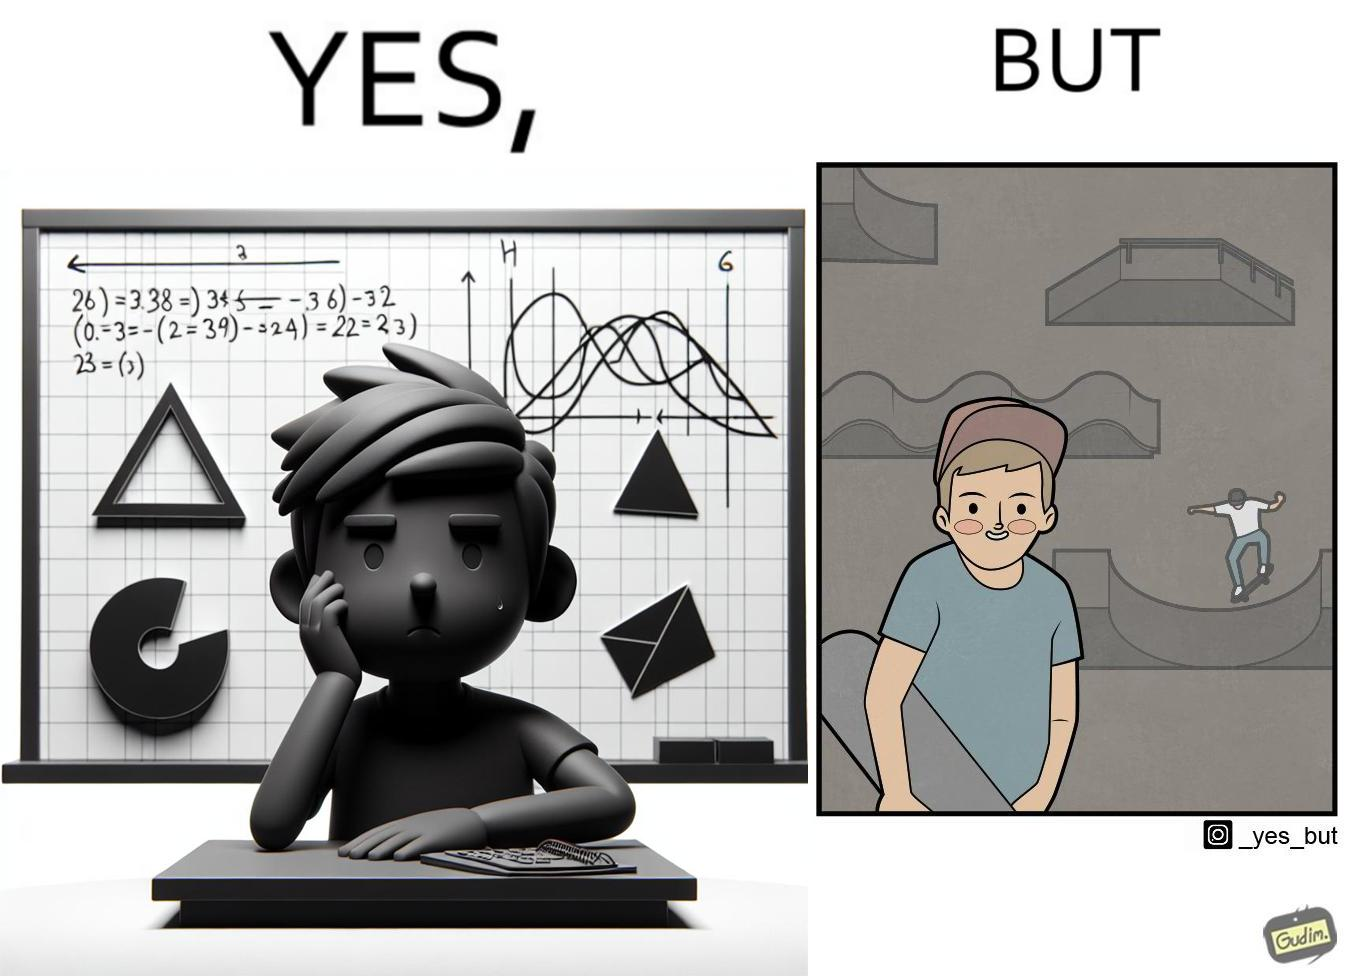Explain the humor or irony in this image. The image is ironical beaucse while the boy does not enjoy studying mathematics and different geometric shapes like semi circle and trapezoid and graphs of trigonometric equations like that of a sine wave, he enjoys skateboarding on surfaces and bowls that are built based on the said geometric shapes and graphs of trigonometric equations. 